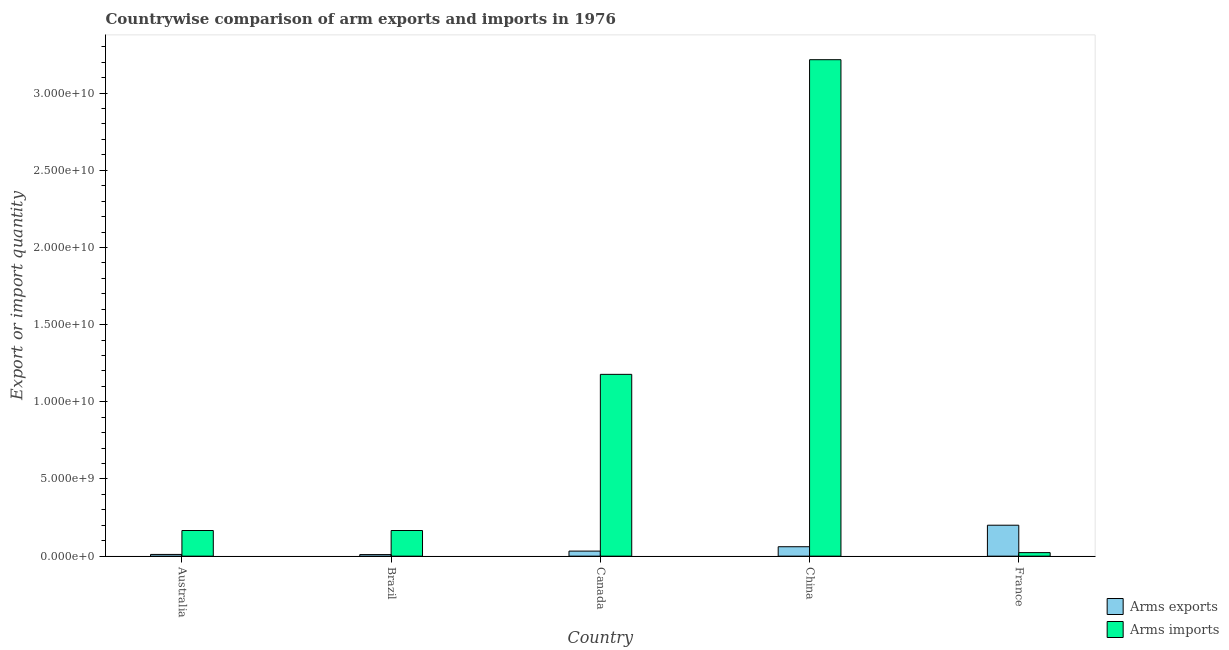Are the number of bars on each tick of the X-axis equal?
Provide a short and direct response. Yes. How many bars are there on the 5th tick from the left?
Your answer should be compact. 2. What is the arms exports in Brazil?
Make the answer very short. 1.03e+08. Across all countries, what is the maximum arms exports?
Offer a terse response. 2.01e+09. Across all countries, what is the minimum arms exports?
Your answer should be compact. 1.03e+08. What is the total arms exports in the graph?
Offer a very short reply. 3.16e+09. What is the difference between the arms imports in Australia and that in Canada?
Keep it short and to the point. -1.01e+1. What is the difference between the arms imports in Australia and the arms exports in China?
Your response must be concise. 1.05e+09. What is the average arms exports per country?
Keep it short and to the point. 6.32e+08. What is the difference between the arms exports and arms imports in Canada?
Ensure brevity in your answer.  -1.15e+1. In how many countries, is the arms exports greater than 7000000000 ?
Offer a terse response. 0. What is the ratio of the arms exports in Australia to that in Brazil?
Give a very brief answer. 1.1. Is the arms exports in Australia less than that in Canada?
Your response must be concise. Yes. Is the difference between the arms imports in Australia and Brazil greater than the difference between the arms exports in Australia and Brazil?
Your answer should be very brief. No. What is the difference between the highest and the second highest arms exports?
Make the answer very short. 1.39e+09. What is the difference between the highest and the lowest arms imports?
Make the answer very short. 3.19e+1. Is the sum of the arms exports in Brazil and Canada greater than the maximum arms imports across all countries?
Provide a succinct answer. No. What does the 1st bar from the left in China represents?
Provide a succinct answer. Arms exports. What does the 2nd bar from the right in Brazil represents?
Your response must be concise. Arms exports. How many bars are there?
Keep it short and to the point. 10. Are all the bars in the graph horizontal?
Provide a short and direct response. No. How many countries are there in the graph?
Provide a succinct answer. 5. What is the difference between two consecutive major ticks on the Y-axis?
Make the answer very short. 5.00e+09. How many legend labels are there?
Offer a very short reply. 2. What is the title of the graph?
Keep it short and to the point. Countrywise comparison of arm exports and imports in 1976. What is the label or title of the X-axis?
Make the answer very short. Country. What is the label or title of the Y-axis?
Your answer should be compact. Export or import quantity. What is the Export or import quantity in Arms exports in Australia?
Ensure brevity in your answer.  1.13e+08. What is the Export or import quantity of Arms imports in Australia?
Your answer should be very brief. 1.66e+09. What is the Export or import quantity of Arms exports in Brazil?
Provide a short and direct response. 1.03e+08. What is the Export or import quantity in Arms imports in Brazil?
Provide a short and direct response. 1.66e+09. What is the Export or import quantity of Arms exports in Canada?
Offer a terse response. 3.28e+08. What is the Export or import quantity of Arms imports in Canada?
Give a very brief answer. 1.18e+1. What is the Export or import quantity of Arms exports in China?
Your response must be concise. 6.12e+08. What is the Export or import quantity of Arms imports in China?
Offer a very short reply. 3.22e+1. What is the Export or import quantity in Arms exports in France?
Your answer should be compact. 2.01e+09. What is the Export or import quantity of Arms imports in France?
Give a very brief answer. 2.30e+08. Across all countries, what is the maximum Export or import quantity in Arms exports?
Your answer should be very brief. 2.01e+09. Across all countries, what is the maximum Export or import quantity in Arms imports?
Give a very brief answer. 3.22e+1. Across all countries, what is the minimum Export or import quantity of Arms exports?
Provide a succinct answer. 1.03e+08. Across all countries, what is the minimum Export or import quantity in Arms imports?
Your answer should be very brief. 2.30e+08. What is the total Export or import quantity of Arms exports in the graph?
Your answer should be very brief. 3.16e+09. What is the total Export or import quantity in Arms imports in the graph?
Give a very brief answer. 4.75e+1. What is the difference between the Export or import quantity of Arms exports in Australia and that in Canada?
Provide a short and direct response. -2.15e+08. What is the difference between the Export or import quantity of Arms imports in Australia and that in Canada?
Offer a very short reply. -1.01e+1. What is the difference between the Export or import quantity in Arms exports in Australia and that in China?
Provide a short and direct response. -4.99e+08. What is the difference between the Export or import quantity in Arms imports in Australia and that in China?
Ensure brevity in your answer.  -3.05e+1. What is the difference between the Export or import quantity in Arms exports in Australia and that in France?
Your answer should be compact. -1.89e+09. What is the difference between the Export or import quantity in Arms imports in Australia and that in France?
Keep it short and to the point. 1.43e+09. What is the difference between the Export or import quantity in Arms exports in Brazil and that in Canada?
Offer a very short reply. -2.25e+08. What is the difference between the Export or import quantity of Arms imports in Brazil and that in Canada?
Your answer should be very brief. -1.01e+1. What is the difference between the Export or import quantity in Arms exports in Brazil and that in China?
Your response must be concise. -5.09e+08. What is the difference between the Export or import quantity in Arms imports in Brazil and that in China?
Provide a succinct answer. -3.05e+1. What is the difference between the Export or import quantity of Arms exports in Brazil and that in France?
Make the answer very short. -1.90e+09. What is the difference between the Export or import quantity of Arms imports in Brazil and that in France?
Your response must be concise. 1.43e+09. What is the difference between the Export or import quantity of Arms exports in Canada and that in China?
Your answer should be compact. -2.84e+08. What is the difference between the Export or import quantity of Arms imports in Canada and that in China?
Your answer should be compact. -2.04e+1. What is the difference between the Export or import quantity of Arms exports in Canada and that in France?
Keep it short and to the point. -1.68e+09. What is the difference between the Export or import quantity in Arms imports in Canada and that in France?
Keep it short and to the point. 1.15e+1. What is the difference between the Export or import quantity of Arms exports in China and that in France?
Keep it short and to the point. -1.39e+09. What is the difference between the Export or import quantity in Arms imports in China and that in France?
Your response must be concise. 3.19e+1. What is the difference between the Export or import quantity of Arms exports in Australia and the Export or import quantity of Arms imports in Brazil?
Your response must be concise. -1.55e+09. What is the difference between the Export or import quantity in Arms exports in Australia and the Export or import quantity in Arms imports in Canada?
Your answer should be very brief. -1.17e+1. What is the difference between the Export or import quantity in Arms exports in Australia and the Export or import quantity in Arms imports in China?
Ensure brevity in your answer.  -3.20e+1. What is the difference between the Export or import quantity of Arms exports in Australia and the Export or import quantity of Arms imports in France?
Make the answer very short. -1.17e+08. What is the difference between the Export or import quantity in Arms exports in Brazil and the Export or import quantity in Arms imports in Canada?
Your answer should be compact. -1.17e+1. What is the difference between the Export or import quantity in Arms exports in Brazil and the Export or import quantity in Arms imports in China?
Keep it short and to the point. -3.21e+1. What is the difference between the Export or import quantity of Arms exports in Brazil and the Export or import quantity of Arms imports in France?
Provide a short and direct response. -1.27e+08. What is the difference between the Export or import quantity of Arms exports in Canada and the Export or import quantity of Arms imports in China?
Provide a short and direct response. -3.18e+1. What is the difference between the Export or import quantity in Arms exports in Canada and the Export or import quantity in Arms imports in France?
Provide a short and direct response. 9.80e+07. What is the difference between the Export or import quantity of Arms exports in China and the Export or import quantity of Arms imports in France?
Give a very brief answer. 3.82e+08. What is the average Export or import quantity of Arms exports per country?
Your answer should be very brief. 6.32e+08. What is the average Export or import quantity in Arms imports per country?
Provide a succinct answer. 9.50e+09. What is the difference between the Export or import quantity in Arms exports and Export or import quantity in Arms imports in Australia?
Your answer should be very brief. -1.55e+09. What is the difference between the Export or import quantity in Arms exports and Export or import quantity in Arms imports in Brazil?
Your response must be concise. -1.56e+09. What is the difference between the Export or import quantity of Arms exports and Export or import quantity of Arms imports in Canada?
Offer a terse response. -1.15e+1. What is the difference between the Export or import quantity in Arms exports and Export or import quantity in Arms imports in China?
Your response must be concise. -3.16e+1. What is the difference between the Export or import quantity in Arms exports and Export or import quantity in Arms imports in France?
Your answer should be compact. 1.78e+09. What is the ratio of the Export or import quantity of Arms exports in Australia to that in Brazil?
Provide a succinct answer. 1.1. What is the ratio of the Export or import quantity in Arms imports in Australia to that in Brazil?
Offer a very short reply. 1. What is the ratio of the Export or import quantity of Arms exports in Australia to that in Canada?
Keep it short and to the point. 0.34. What is the ratio of the Export or import quantity of Arms imports in Australia to that in Canada?
Provide a succinct answer. 0.14. What is the ratio of the Export or import quantity of Arms exports in Australia to that in China?
Your answer should be very brief. 0.18. What is the ratio of the Export or import quantity of Arms imports in Australia to that in China?
Your response must be concise. 0.05. What is the ratio of the Export or import quantity in Arms exports in Australia to that in France?
Your response must be concise. 0.06. What is the ratio of the Export or import quantity of Arms imports in Australia to that in France?
Offer a terse response. 7.23. What is the ratio of the Export or import quantity in Arms exports in Brazil to that in Canada?
Provide a short and direct response. 0.31. What is the ratio of the Export or import quantity in Arms imports in Brazil to that in Canada?
Your answer should be very brief. 0.14. What is the ratio of the Export or import quantity of Arms exports in Brazil to that in China?
Give a very brief answer. 0.17. What is the ratio of the Export or import quantity in Arms imports in Brazil to that in China?
Make the answer very short. 0.05. What is the ratio of the Export or import quantity in Arms exports in Brazil to that in France?
Provide a short and direct response. 0.05. What is the ratio of the Export or import quantity of Arms imports in Brazil to that in France?
Offer a terse response. 7.23. What is the ratio of the Export or import quantity in Arms exports in Canada to that in China?
Give a very brief answer. 0.54. What is the ratio of the Export or import quantity in Arms imports in Canada to that in China?
Keep it short and to the point. 0.37. What is the ratio of the Export or import quantity in Arms exports in Canada to that in France?
Keep it short and to the point. 0.16. What is the ratio of the Export or import quantity in Arms imports in Canada to that in France?
Your answer should be very brief. 51.21. What is the ratio of the Export or import quantity in Arms exports in China to that in France?
Offer a very short reply. 0.31. What is the ratio of the Export or import quantity in Arms imports in China to that in France?
Ensure brevity in your answer.  139.84. What is the difference between the highest and the second highest Export or import quantity in Arms exports?
Offer a terse response. 1.39e+09. What is the difference between the highest and the second highest Export or import quantity in Arms imports?
Your answer should be very brief. 2.04e+1. What is the difference between the highest and the lowest Export or import quantity in Arms exports?
Your answer should be compact. 1.90e+09. What is the difference between the highest and the lowest Export or import quantity in Arms imports?
Ensure brevity in your answer.  3.19e+1. 